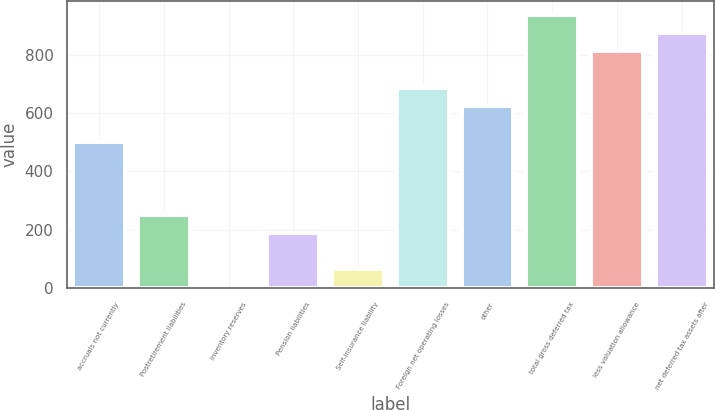Convert chart to OTSL. <chart><loc_0><loc_0><loc_500><loc_500><bar_chart><fcel>accruals not currently<fcel>Postretirement liabilities<fcel>inventory reserves<fcel>Pension liabilities<fcel>Self-insurance liability<fcel>Foreign net operating losses<fcel>other<fcel>total gross deferred tax<fcel>less valuation allowance<fcel>net deferred tax assets after<nl><fcel>499.92<fcel>250.96<fcel>2<fcel>188.72<fcel>64.24<fcel>686.64<fcel>624.4<fcel>935.6<fcel>811.12<fcel>873.36<nl></chart> 